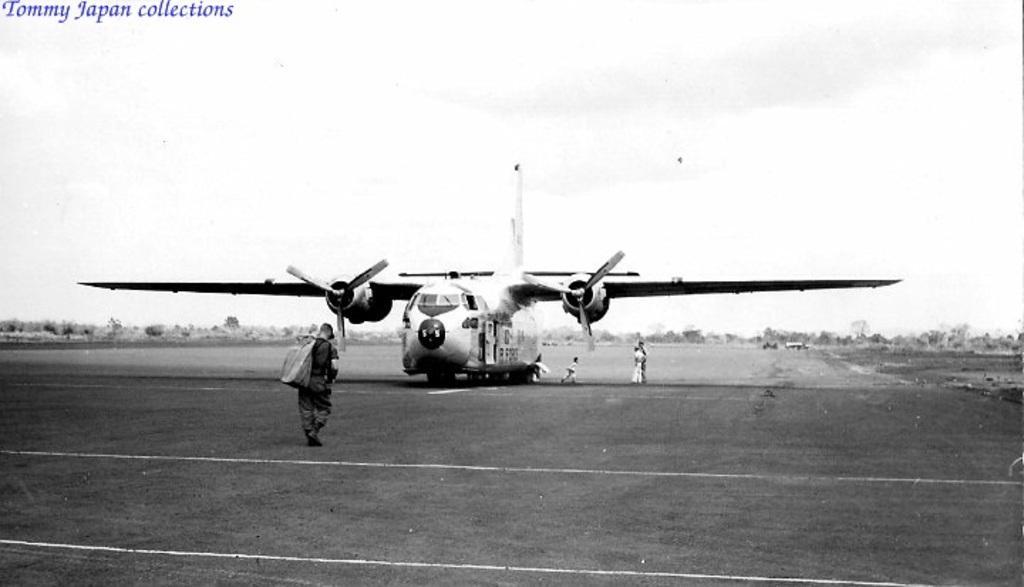Please provide a concise description of this image. In this image I can see few persons and I can also see an aircraft, background I can see few trees and the sky and the image is in black and white. 